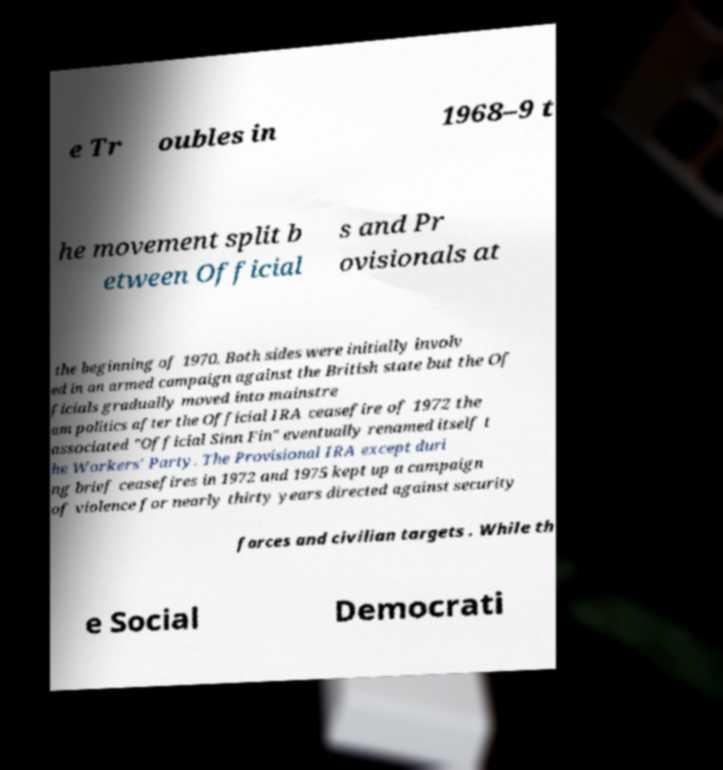For documentation purposes, I need the text within this image transcribed. Could you provide that? e Tr oubles in 1968–9 t he movement split b etween Official s and Pr ovisionals at the beginning of 1970. Both sides were initially involv ed in an armed campaign against the British state but the Of ficials gradually moved into mainstre am politics after the Official IRA ceasefire of 1972 the associated "Official Sinn Fin" eventually renamed itself t he Workers' Party. The Provisional IRA except duri ng brief ceasefires in 1972 and 1975 kept up a campaign of violence for nearly thirty years directed against security forces and civilian targets . While th e Social Democrati 